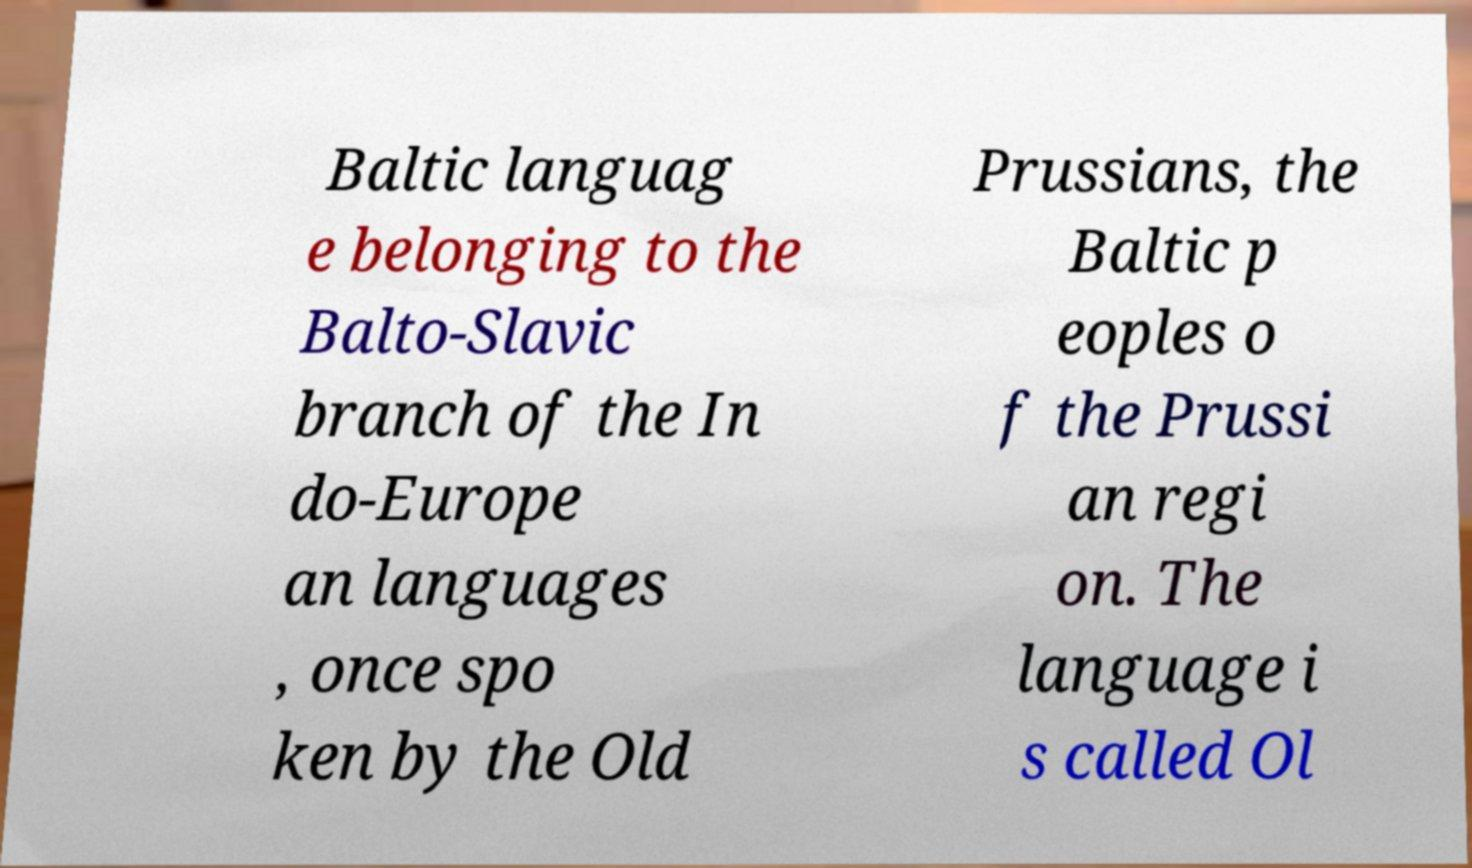Can you read and provide the text displayed in the image?This photo seems to have some interesting text. Can you extract and type it out for me? Baltic languag e belonging to the Balto-Slavic branch of the In do-Europe an languages , once spo ken by the Old Prussians, the Baltic p eoples o f the Prussi an regi on. The language i s called Ol 